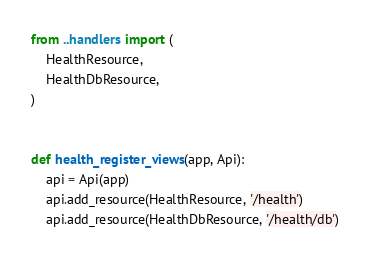Convert code to text. <code><loc_0><loc_0><loc_500><loc_500><_Python_>from ..handlers import (
    HealthResource,
    HealthDbResource,
)


def health_register_views(app, Api):
    api = Api(app)
    api.add_resource(HealthResource, '/health')
    api.add_resource(HealthDbResource, '/health/db')
</code> 